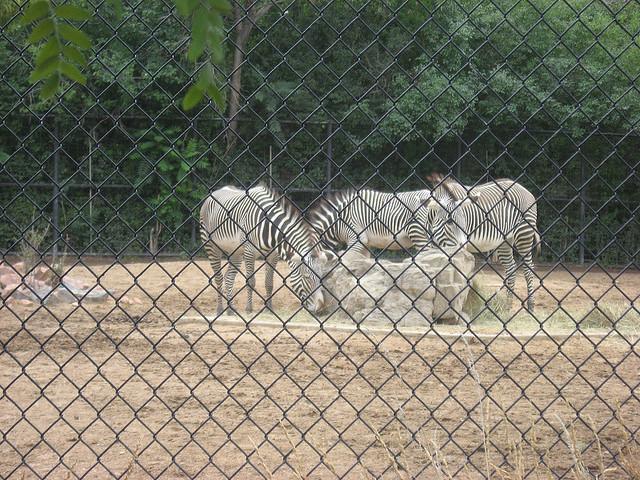How many zebras are there?
Give a very brief answer. 3. How many zebras are in the photo?
Give a very brief answer. 3. 